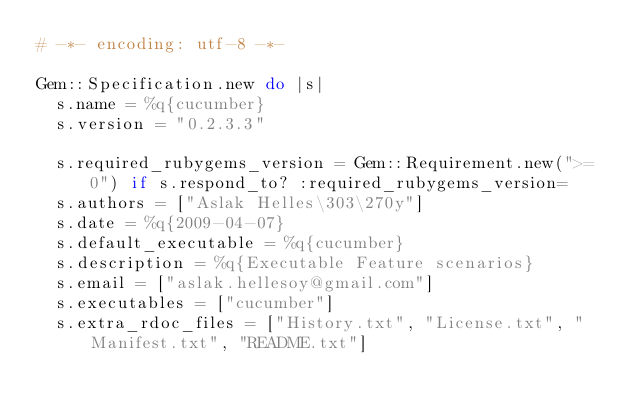Convert code to text. <code><loc_0><loc_0><loc_500><loc_500><_Ruby_># -*- encoding: utf-8 -*-

Gem::Specification.new do |s|
  s.name = %q{cucumber}
  s.version = "0.2.3.3"

  s.required_rubygems_version = Gem::Requirement.new(">= 0") if s.respond_to? :required_rubygems_version=
  s.authors = ["Aslak Helles\303\270y"]
  s.date = %q{2009-04-07}
  s.default_executable = %q{cucumber}
  s.description = %q{Executable Feature scenarios}
  s.email = ["aslak.hellesoy@gmail.com"]
  s.executables = ["cucumber"]
  s.extra_rdoc_files = ["History.txt", "License.txt", "Manifest.txt", "README.txt"]</code> 